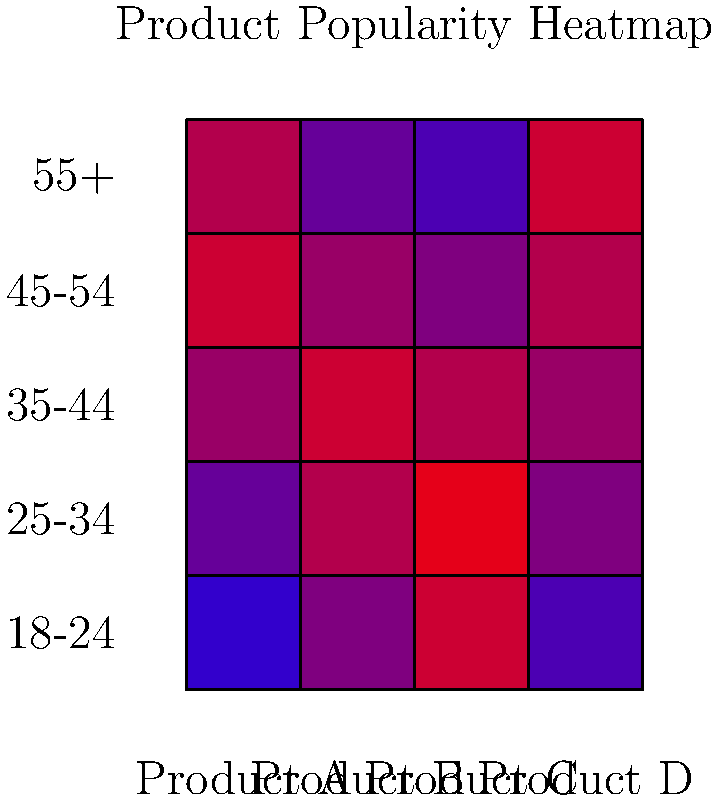Based on the heatmap showing product popularity across different demographic segments, which product demonstrates the strongest appeal to the youngest age group (18-24) and how does its popularity trend change across older demographics? To answer this question, we need to analyze the heatmap data for each product across the different age groups, focusing on the 18-24 column and observing the trend as we move to older demographics.

1. Examine the 18-24 column for each product:
   - Product A: Light blue (low popularity)
   - Product B: Green (moderate popularity)
   - Product C: Red (highest popularity)
   - Product D: Light green (low to moderate popularity)

2. Product C shows the strongest appeal to the 18-24 age group, as indicated by the red color (highest intensity).

3. Observe the trend for Product C across older demographics:
   - 18-24: Red (highest popularity)
   - 25-34: Red (remains high)
   - 35-44: Yellow-green (decreases)
   - 45-54: Green (further decrease)
   - 55+: Blue (significant decrease)

4. The trend shows a clear decline in popularity for Product C as the age groups get older, moving from red (high popularity) to blue (low popularity).
Answer: Product C; popularity decreases with age 